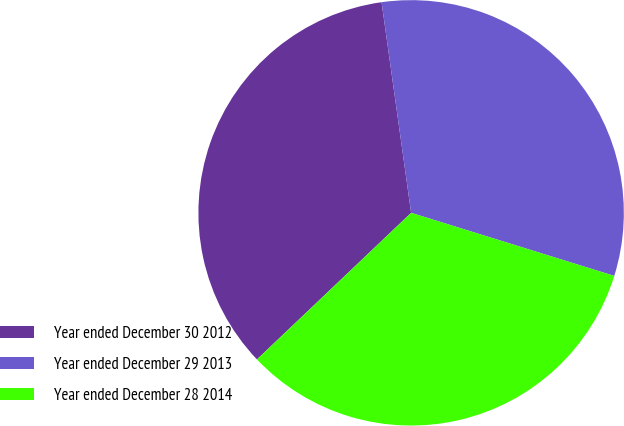Convert chart. <chart><loc_0><loc_0><loc_500><loc_500><pie_chart><fcel>Year ended December 30 2012<fcel>Year ended December 29 2013<fcel>Year ended December 28 2014<nl><fcel>34.88%<fcel>32.01%<fcel>33.11%<nl></chart> 